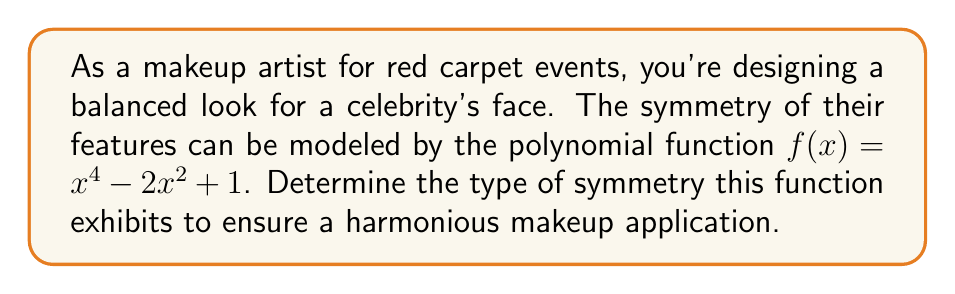Help me with this question. To determine the symmetry of the polynomial function $f(x) = x^4 - 2x^2 + 1$, we need to follow these steps:

1. Check for even function symmetry:
   An even function is symmetric about the y-axis, satisfying $f(x) = f(-x)$ for all $x$.
   
   Let's substitute $-x$ into the function:
   $f(-x) = (-x)^4 - 2(-x)^2 + 1$
   $= x^4 - 2x^2 + 1$
   $= f(x)$

   Since $f(-x) = f(x)$, the function is even.

2. Check for odd function symmetry:
   An odd function is symmetric about the origin, satisfying $f(-x) = -f(x)$ for all $x$.
   We've already shown that $f(-x) = f(x)$, so it's not an odd function.

3. Check for point symmetry:
   Point symmetry occurs when a function is both even and odd. Since our function is even but not odd, it doesn't have point symmetry.

Therefore, the polynomial function $f(x) = x^4 - 2x^2 + 1$ exhibits even function symmetry, which means it's symmetric about the y-axis. This implies that the makeup design should be balanced equally on both sides of the face, mirroring each other across the vertical centerline.
Answer: Even symmetry (y-axis symmetry) 